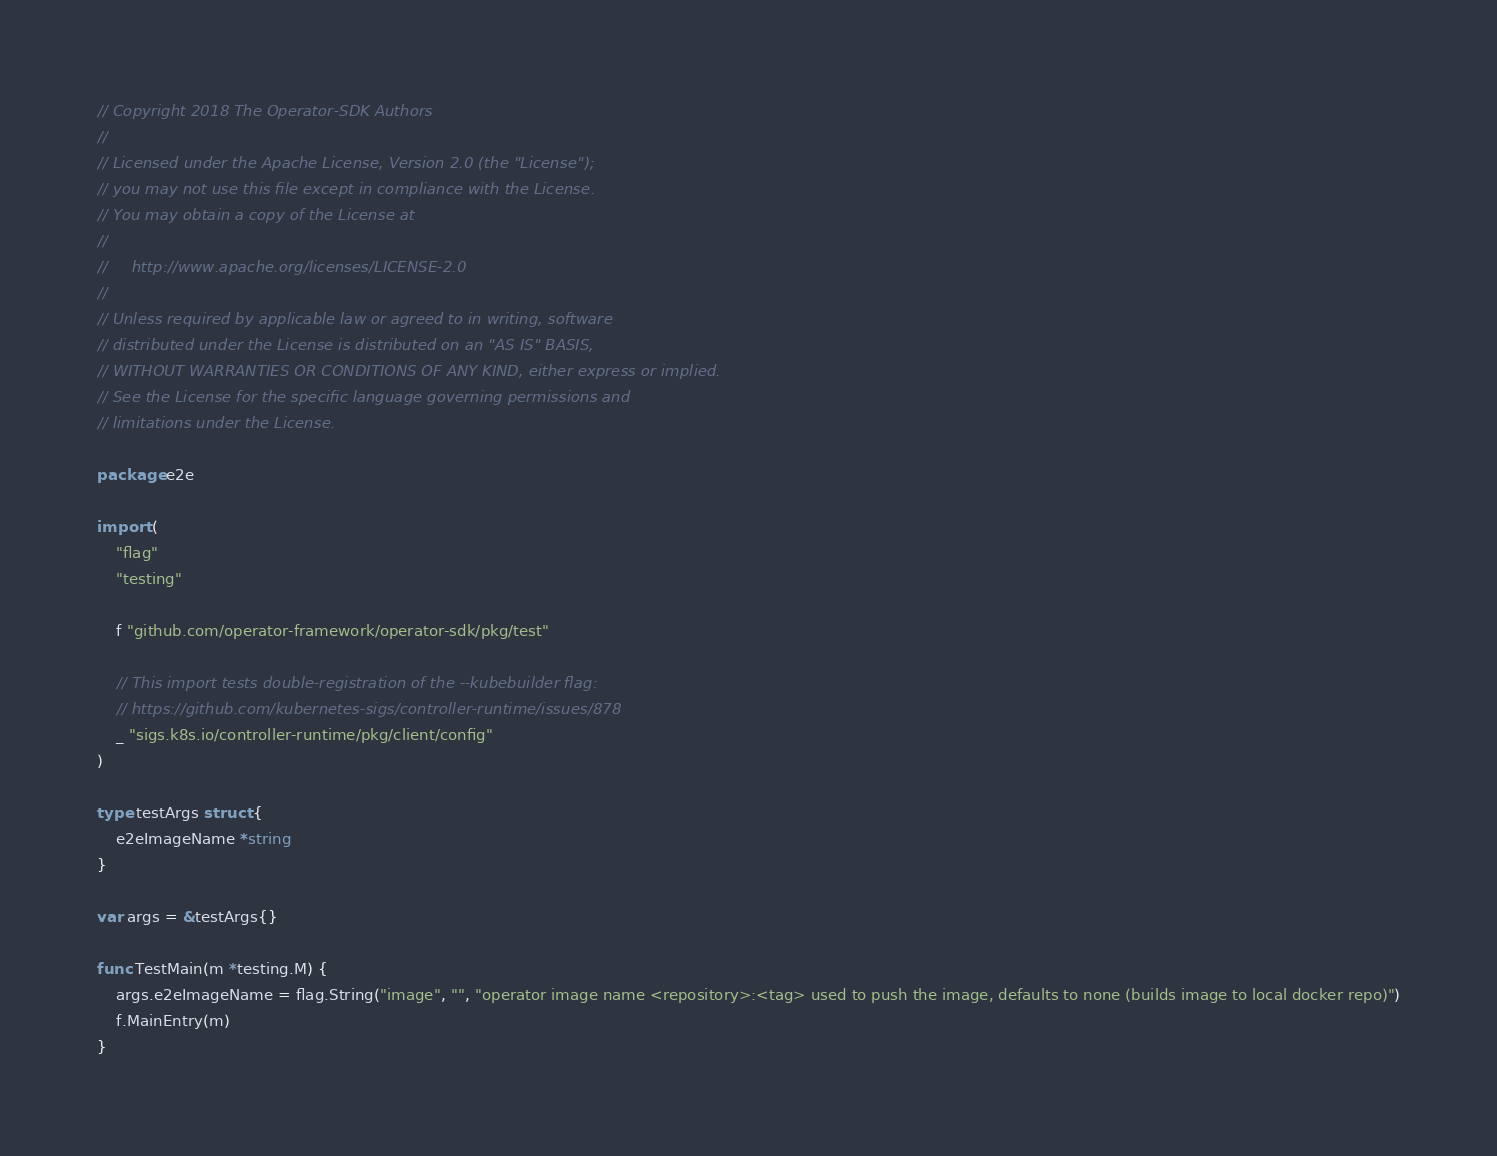<code> <loc_0><loc_0><loc_500><loc_500><_Go_>// Copyright 2018 The Operator-SDK Authors
//
// Licensed under the Apache License, Version 2.0 (the "License");
// you may not use this file except in compliance with the License.
// You may obtain a copy of the License at
//
//     http://www.apache.org/licenses/LICENSE-2.0
//
// Unless required by applicable law or agreed to in writing, software
// distributed under the License is distributed on an "AS IS" BASIS,
// WITHOUT WARRANTIES OR CONDITIONS OF ANY KIND, either express or implied.
// See the License for the specific language governing permissions and
// limitations under the License.

package e2e

import (
	"flag"
	"testing"

	f "github.com/operator-framework/operator-sdk/pkg/test"

	// This import tests double-registration of the --kubebuilder flag:
	// https://github.com/kubernetes-sigs/controller-runtime/issues/878
	_ "sigs.k8s.io/controller-runtime/pkg/client/config"
)

type testArgs struct {
	e2eImageName *string
}

var args = &testArgs{}

func TestMain(m *testing.M) {
	args.e2eImageName = flag.String("image", "", "operator image name <repository>:<tag> used to push the image, defaults to none (builds image to local docker repo)")
	f.MainEntry(m)
}
</code> 